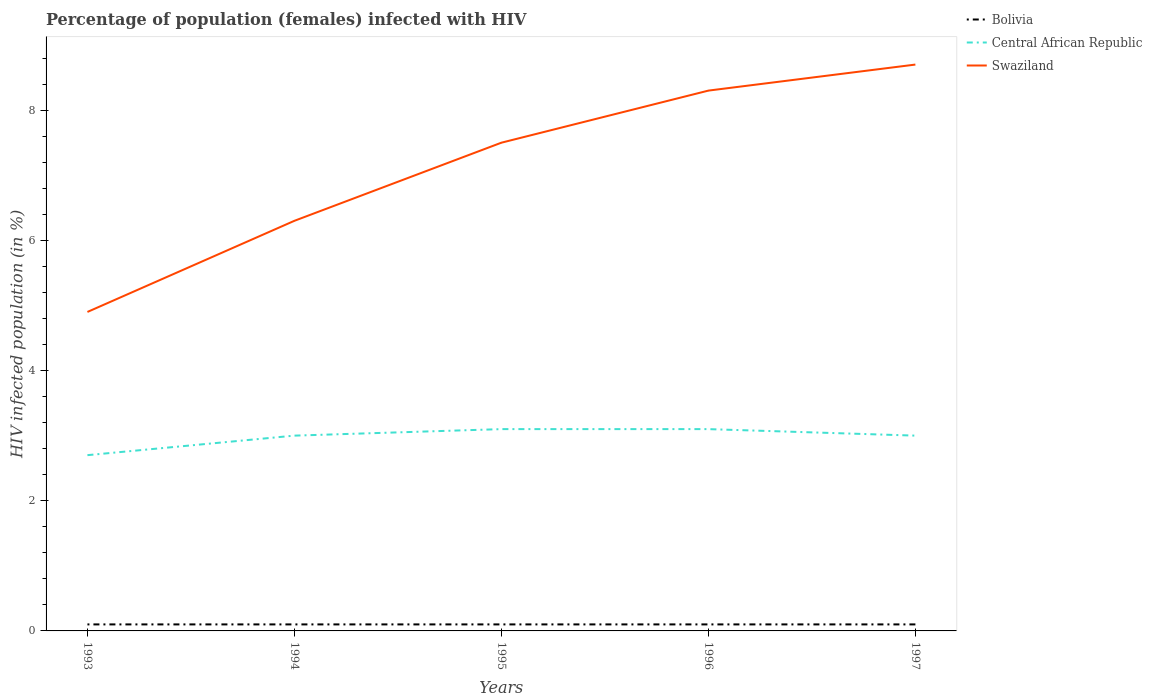Is the number of lines equal to the number of legend labels?
Keep it short and to the point. Yes. What is the total percentage of HIV infected female population in Swaziland in the graph?
Offer a very short reply. -1.2. What is the difference between the highest and the lowest percentage of HIV infected female population in Swaziland?
Give a very brief answer. 3. Is the percentage of HIV infected female population in Swaziland strictly greater than the percentage of HIV infected female population in Central African Republic over the years?
Provide a succinct answer. No. Does the graph contain any zero values?
Make the answer very short. No. Where does the legend appear in the graph?
Your answer should be very brief. Top right. How many legend labels are there?
Your response must be concise. 3. How are the legend labels stacked?
Ensure brevity in your answer.  Vertical. What is the title of the graph?
Provide a succinct answer. Percentage of population (females) infected with HIV. What is the label or title of the X-axis?
Give a very brief answer. Years. What is the label or title of the Y-axis?
Provide a succinct answer. HIV infected population (in %). What is the HIV infected population (in %) of Swaziland in 1993?
Keep it short and to the point. 4.9. What is the HIV infected population (in %) of Bolivia in 1994?
Offer a very short reply. 0.1. What is the HIV infected population (in %) of Central African Republic in 1994?
Offer a very short reply. 3. What is the HIV infected population (in %) in Bolivia in 1995?
Your answer should be compact. 0.1. What is the HIV infected population (in %) in Central African Republic in 1995?
Offer a very short reply. 3.1. What is the HIV infected population (in %) in Swaziland in 1995?
Your answer should be very brief. 7.5. What is the HIV infected population (in %) in Bolivia in 1996?
Provide a short and direct response. 0.1. What is the HIV infected population (in %) of Central African Republic in 1996?
Offer a terse response. 3.1. What is the HIV infected population (in %) in Swaziland in 1997?
Keep it short and to the point. 8.7. Across all years, what is the maximum HIV infected population (in %) of Bolivia?
Ensure brevity in your answer.  0.1. Across all years, what is the minimum HIV infected population (in %) of Bolivia?
Keep it short and to the point. 0.1. Across all years, what is the minimum HIV infected population (in %) of Central African Republic?
Your answer should be very brief. 2.7. What is the total HIV infected population (in %) in Bolivia in the graph?
Keep it short and to the point. 0.5. What is the total HIV infected population (in %) in Swaziland in the graph?
Give a very brief answer. 35.7. What is the difference between the HIV infected population (in %) in Central African Republic in 1993 and that in 1994?
Your answer should be compact. -0.3. What is the difference between the HIV infected population (in %) of Swaziland in 1993 and that in 1994?
Provide a succinct answer. -1.4. What is the difference between the HIV infected population (in %) in Central African Republic in 1993 and that in 1996?
Your answer should be compact. -0.4. What is the difference between the HIV infected population (in %) in Swaziland in 1993 and that in 1996?
Make the answer very short. -3.4. What is the difference between the HIV infected population (in %) in Bolivia in 1993 and that in 1997?
Provide a short and direct response. 0. What is the difference between the HIV infected population (in %) in Central African Republic in 1993 and that in 1997?
Offer a terse response. -0.3. What is the difference between the HIV infected population (in %) in Swaziland in 1993 and that in 1997?
Your answer should be compact. -3.8. What is the difference between the HIV infected population (in %) in Swaziland in 1994 and that in 1995?
Make the answer very short. -1.2. What is the difference between the HIV infected population (in %) in Central African Republic in 1994 and that in 1996?
Your response must be concise. -0.1. What is the difference between the HIV infected population (in %) of Swaziland in 1994 and that in 1996?
Your response must be concise. -2. What is the difference between the HIV infected population (in %) of Bolivia in 1994 and that in 1997?
Provide a succinct answer. 0. What is the difference between the HIV infected population (in %) of Central African Republic in 1994 and that in 1997?
Provide a short and direct response. 0. What is the difference between the HIV infected population (in %) of Swaziland in 1994 and that in 1997?
Keep it short and to the point. -2.4. What is the difference between the HIV infected population (in %) of Central African Republic in 1995 and that in 1996?
Give a very brief answer. 0. What is the difference between the HIV infected population (in %) of Central African Republic in 1995 and that in 1997?
Ensure brevity in your answer.  0.1. What is the difference between the HIV infected population (in %) of Central African Republic in 1993 and the HIV infected population (in %) of Swaziland in 1994?
Keep it short and to the point. -3.6. What is the difference between the HIV infected population (in %) in Bolivia in 1993 and the HIV infected population (in %) in Central African Republic in 1995?
Your answer should be very brief. -3. What is the difference between the HIV infected population (in %) of Bolivia in 1993 and the HIV infected population (in %) of Swaziland in 1996?
Provide a succinct answer. -8.2. What is the difference between the HIV infected population (in %) of Bolivia in 1993 and the HIV infected population (in %) of Swaziland in 1997?
Your answer should be compact. -8.6. What is the difference between the HIV infected population (in %) in Bolivia in 1994 and the HIV infected population (in %) in Central African Republic in 1995?
Ensure brevity in your answer.  -3. What is the difference between the HIV infected population (in %) in Bolivia in 1994 and the HIV infected population (in %) in Swaziland in 1995?
Offer a very short reply. -7.4. What is the difference between the HIV infected population (in %) in Central African Republic in 1994 and the HIV infected population (in %) in Swaziland in 1995?
Your response must be concise. -4.5. What is the difference between the HIV infected population (in %) in Bolivia in 1994 and the HIV infected population (in %) in Swaziland in 1997?
Your response must be concise. -8.6. What is the difference between the HIV infected population (in %) of Bolivia in 1995 and the HIV infected population (in %) of Central African Republic in 1996?
Provide a short and direct response. -3. What is the difference between the HIV infected population (in %) in Bolivia in 1995 and the HIV infected population (in %) in Central African Republic in 1997?
Your answer should be very brief. -2.9. What is the difference between the HIV infected population (in %) in Bolivia in 1995 and the HIV infected population (in %) in Swaziland in 1997?
Make the answer very short. -8.6. What is the difference between the HIV infected population (in %) in Central African Republic in 1995 and the HIV infected population (in %) in Swaziland in 1997?
Make the answer very short. -5.6. What is the difference between the HIV infected population (in %) of Bolivia in 1996 and the HIV infected population (in %) of Swaziland in 1997?
Offer a very short reply. -8.6. What is the average HIV infected population (in %) in Central African Republic per year?
Your response must be concise. 2.98. What is the average HIV infected population (in %) of Swaziland per year?
Give a very brief answer. 7.14. In the year 1993, what is the difference between the HIV infected population (in %) of Central African Republic and HIV infected population (in %) of Swaziland?
Your answer should be compact. -2.2. In the year 1994, what is the difference between the HIV infected population (in %) of Bolivia and HIV infected population (in %) of Central African Republic?
Make the answer very short. -2.9. In the year 1994, what is the difference between the HIV infected population (in %) of Bolivia and HIV infected population (in %) of Swaziland?
Provide a short and direct response. -6.2. In the year 1994, what is the difference between the HIV infected population (in %) of Central African Republic and HIV infected population (in %) of Swaziland?
Provide a succinct answer. -3.3. In the year 1995, what is the difference between the HIV infected population (in %) in Bolivia and HIV infected population (in %) in Swaziland?
Your response must be concise. -7.4. In the year 1997, what is the difference between the HIV infected population (in %) in Bolivia and HIV infected population (in %) in Swaziland?
Ensure brevity in your answer.  -8.6. In the year 1997, what is the difference between the HIV infected population (in %) of Central African Republic and HIV infected population (in %) of Swaziland?
Keep it short and to the point. -5.7. What is the ratio of the HIV infected population (in %) in Bolivia in 1993 to that in 1994?
Keep it short and to the point. 1. What is the ratio of the HIV infected population (in %) in Central African Republic in 1993 to that in 1994?
Ensure brevity in your answer.  0.9. What is the ratio of the HIV infected population (in %) in Swaziland in 1993 to that in 1994?
Keep it short and to the point. 0.78. What is the ratio of the HIV infected population (in %) in Bolivia in 1993 to that in 1995?
Provide a short and direct response. 1. What is the ratio of the HIV infected population (in %) of Central African Republic in 1993 to that in 1995?
Give a very brief answer. 0.87. What is the ratio of the HIV infected population (in %) of Swaziland in 1993 to that in 1995?
Your response must be concise. 0.65. What is the ratio of the HIV infected population (in %) in Central African Republic in 1993 to that in 1996?
Offer a terse response. 0.87. What is the ratio of the HIV infected population (in %) of Swaziland in 1993 to that in 1996?
Give a very brief answer. 0.59. What is the ratio of the HIV infected population (in %) in Bolivia in 1993 to that in 1997?
Give a very brief answer. 1. What is the ratio of the HIV infected population (in %) in Central African Republic in 1993 to that in 1997?
Keep it short and to the point. 0.9. What is the ratio of the HIV infected population (in %) of Swaziland in 1993 to that in 1997?
Offer a very short reply. 0.56. What is the ratio of the HIV infected population (in %) of Swaziland in 1994 to that in 1995?
Provide a short and direct response. 0.84. What is the ratio of the HIV infected population (in %) of Bolivia in 1994 to that in 1996?
Offer a terse response. 1. What is the ratio of the HIV infected population (in %) in Swaziland in 1994 to that in 1996?
Make the answer very short. 0.76. What is the ratio of the HIV infected population (in %) of Swaziland in 1994 to that in 1997?
Your answer should be compact. 0.72. What is the ratio of the HIV infected population (in %) of Swaziland in 1995 to that in 1996?
Your answer should be compact. 0.9. What is the ratio of the HIV infected population (in %) of Bolivia in 1995 to that in 1997?
Make the answer very short. 1. What is the ratio of the HIV infected population (in %) in Swaziland in 1995 to that in 1997?
Give a very brief answer. 0.86. What is the ratio of the HIV infected population (in %) in Swaziland in 1996 to that in 1997?
Make the answer very short. 0.95. What is the difference between the highest and the second highest HIV infected population (in %) in Bolivia?
Offer a terse response. 0. What is the difference between the highest and the second highest HIV infected population (in %) in Central African Republic?
Make the answer very short. 0. What is the difference between the highest and the lowest HIV infected population (in %) in Bolivia?
Your answer should be very brief. 0. What is the difference between the highest and the lowest HIV infected population (in %) of Swaziland?
Ensure brevity in your answer.  3.8. 